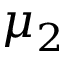Convert formula to latex. <formula><loc_0><loc_0><loc_500><loc_500>\mu _ { 2 }</formula> 